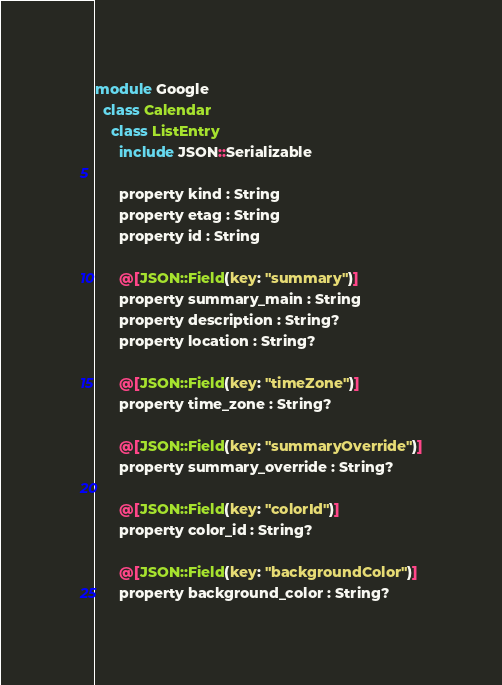<code> <loc_0><loc_0><loc_500><loc_500><_Crystal_>module Google
  class Calendar
    class ListEntry
      include JSON::Serializable

      property kind : String
      property etag : String
      property id : String

      @[JSON::Field(key: "summary")]
      property summary_main : String
      property description : String?
      property location : String?

      @[JSON::Field(key: "timeZone")]
      property time_zone : String?

      @[JSON::Field(key: "summaryOverride")]
      property summary_override : String?

      @[JSON::Field(key: "colorId")]
      property color_id : String?

      @[JSON::Field(key: "backgroundColor")]
      property background_color : String?
</code> 